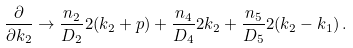<formula> <loc_0><loc_0><loc_500><loc_500>\frac { \partial } { \partial k _ { 2 } } \to \frac { n _ { 2 } } { D _ { 2 } } 2 ( k _ { 2 } + p ) + \frac { n _ { 4 } } { D _ { 4 } } 2 k _ { 2 } + \frac { n _ { 5 } } { D _ { 5 } } 2 ( k _ { 2 } - k _ { 1 } ) \, .</formula> 